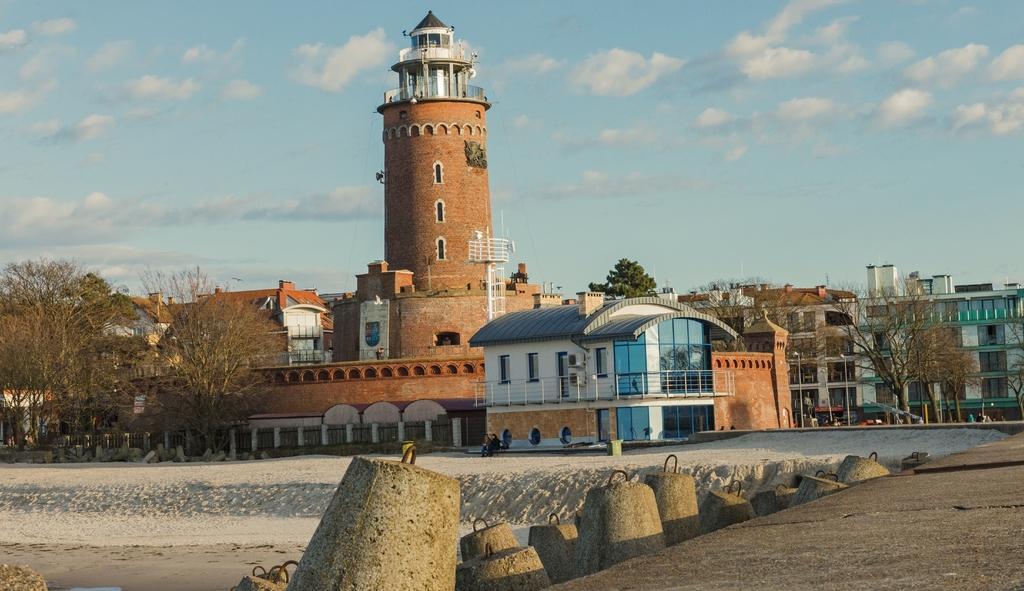How would you summarize this image in a sentence or two? This picture is clicked outside the city. On the right side, we see the road. Beside that, we see the cement blocks. In the middle, we see two people are standing. On the right side, we see the people are standing and we see a red color car. There are trees, buildings, poles and a tower in the background. At the top, we see the sky and the clouds. 